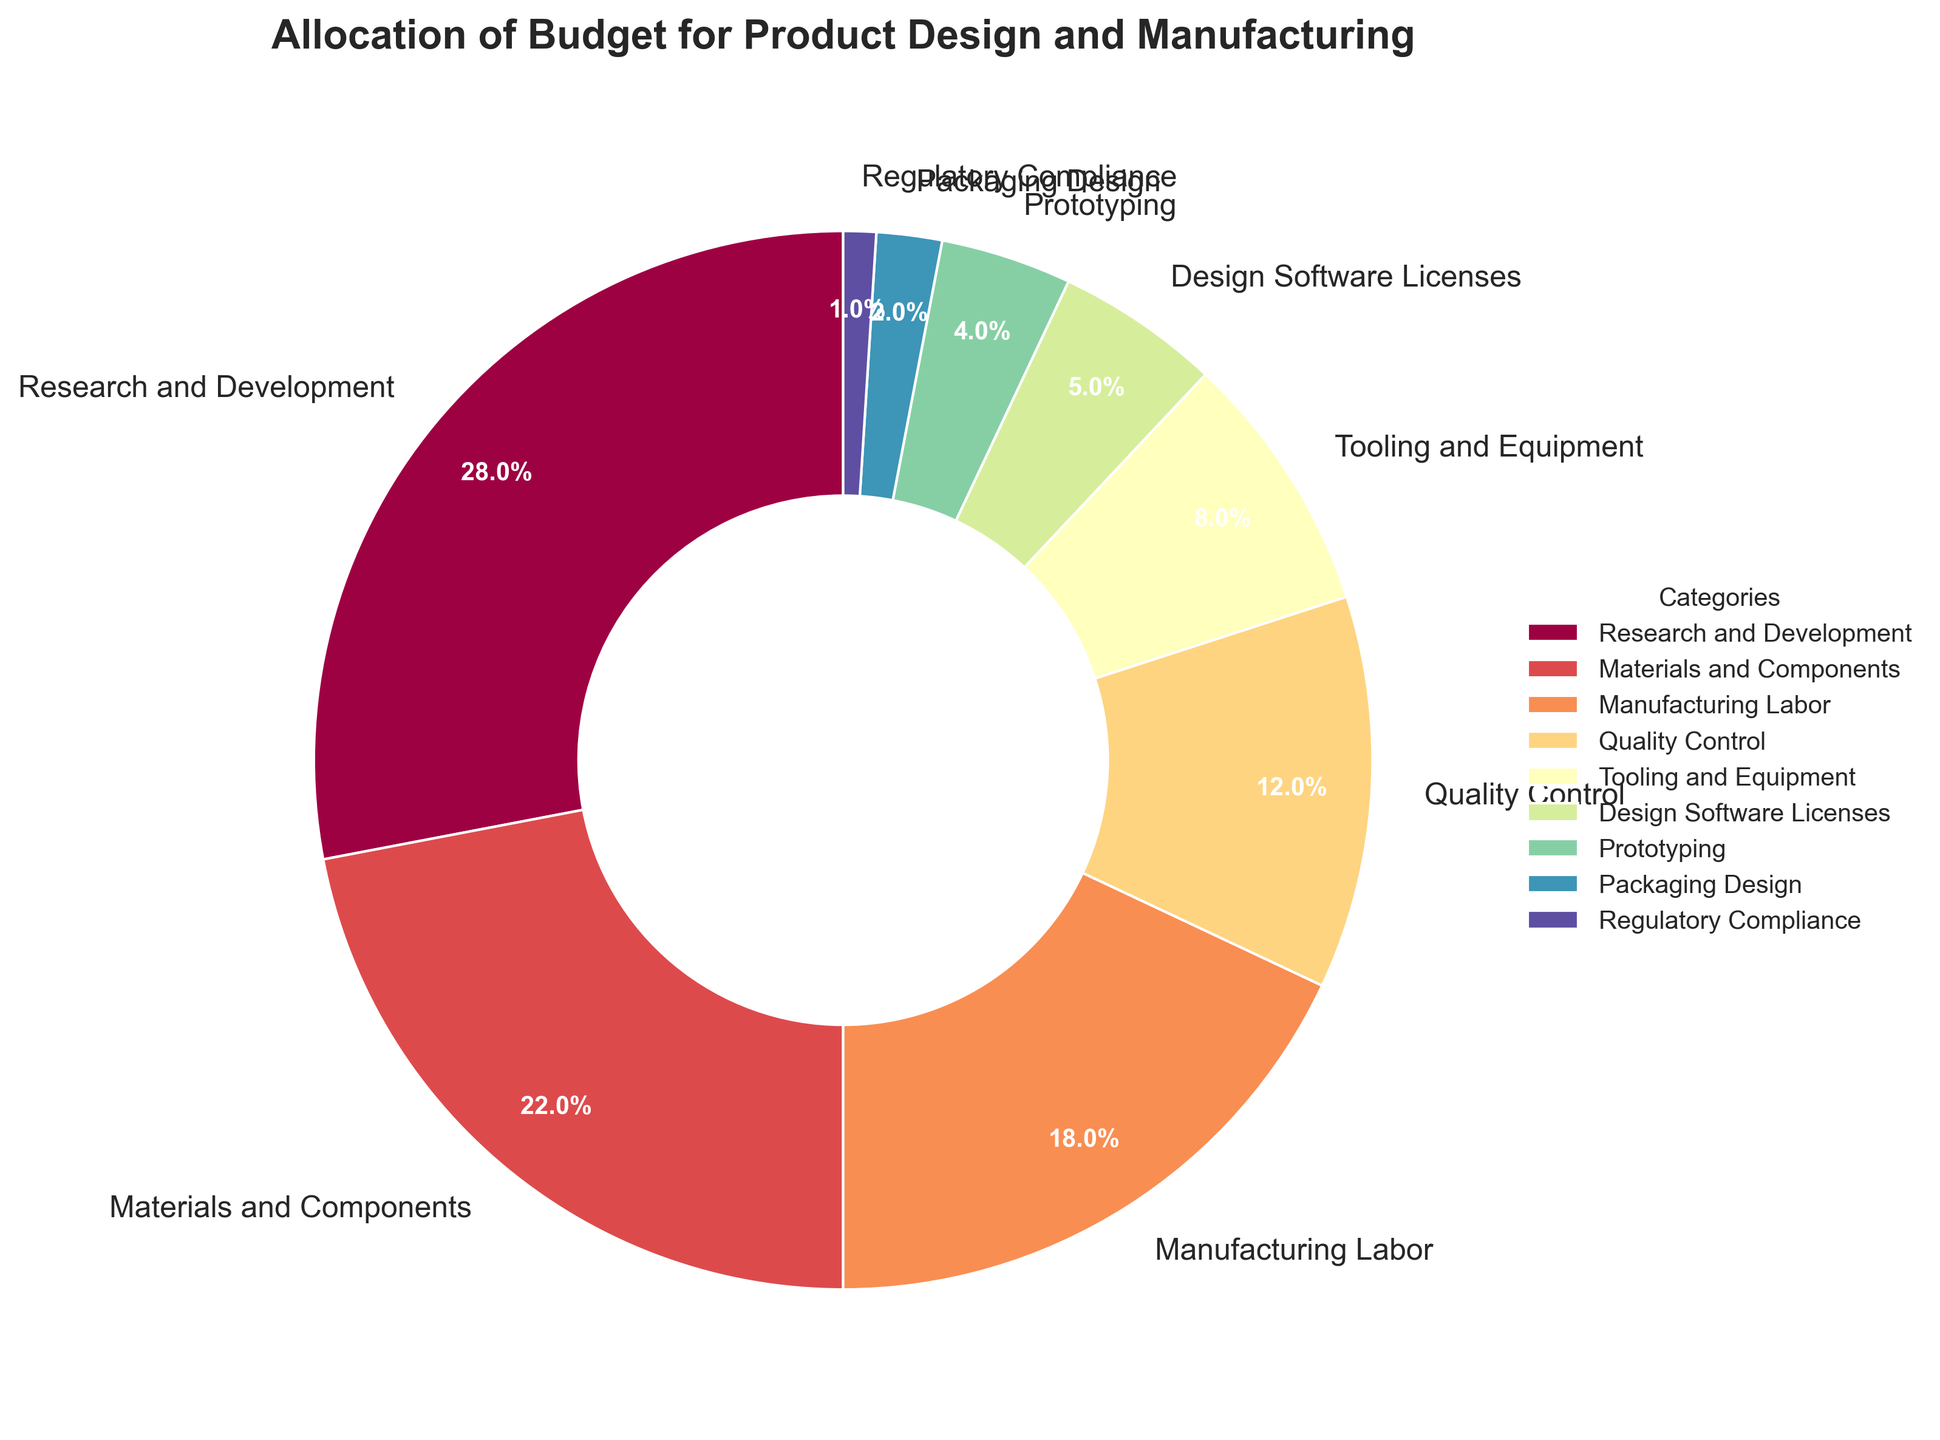What percentage of the budget is allocated to the top three categories combined? The top three categories by percentage are Research and Development (28%), Materials and Components (22%), and Manufacturing Labor (18%). Summing these percentages gives 28% + 22% + 18% = 68%.
Answer: 68% Which category has the smallest budget allocation, and what is its percentage? The category with the smallest budget allocation is Regulatory Compliance, which has a 1% share of the budget.
Answer: Regulatory Compliance, 1% How much more budget percentage is allocated to Research and Development compared to Manufacturing Labor? The budget for Research and Development is 28% and for Manufacturing Labor is 18%. The difference is 28% - 18% = 10%.
Answer: 10% Is the budget allocation for Quality Control greater than or less than the combined allocation for Prototyping and Packaging Design? Quality Control has a 12% allocation. Prototyping has 4% and Packaging Design has 2%. Combined, Prototyping and Packaging Design have 4% + 2% = 6%, which is less than Quality Control's 12%.
Answer: Greater What is the average budget allocation for Tooling and Equipment, Design Software Licenses, Prototyping, and Packaging Design? The percentages are Tooling and Equipment (8%), Design Software Licenses (5%), Prototyping (4%), and Packaging Design (2%). Summing these gives 8% + 5% + 4% + 2% = 19%. The average is 19% / 4 = 4.75%.
Answer: 4.75% Which category uses the color closest to the center of the color spectrum in the pie chart? The categories use colors transitioning through a color spectrum. Based on typical spectrum placement, the middle category would likely be Manufacturing Labor, given it's often mid-way through the color transitions.
Answer: Manufacturing Labor How does the budget percentage for Materials and Components compare to the combined percentage for Tooling and Equipment and Design Software Licenses? Materials and Components have a 22% allocation. Tooling and Equipment and Design Software Licenses have 8% and 5% respectively, combined to 8% + 5% = 13%. Therefore, Materials and Components have a higher allocation.
Answer: Higher If the budget for Prototyping were increased to 7%, which category would then have the smallest budget? Prototyping currently has 4%. Increasing it to 7% would change the smallest budget allocation to Packaging Design (currently 2%) as Regulatory Compliance is already higher at 1%.
Answer: Regulatory Compliance 